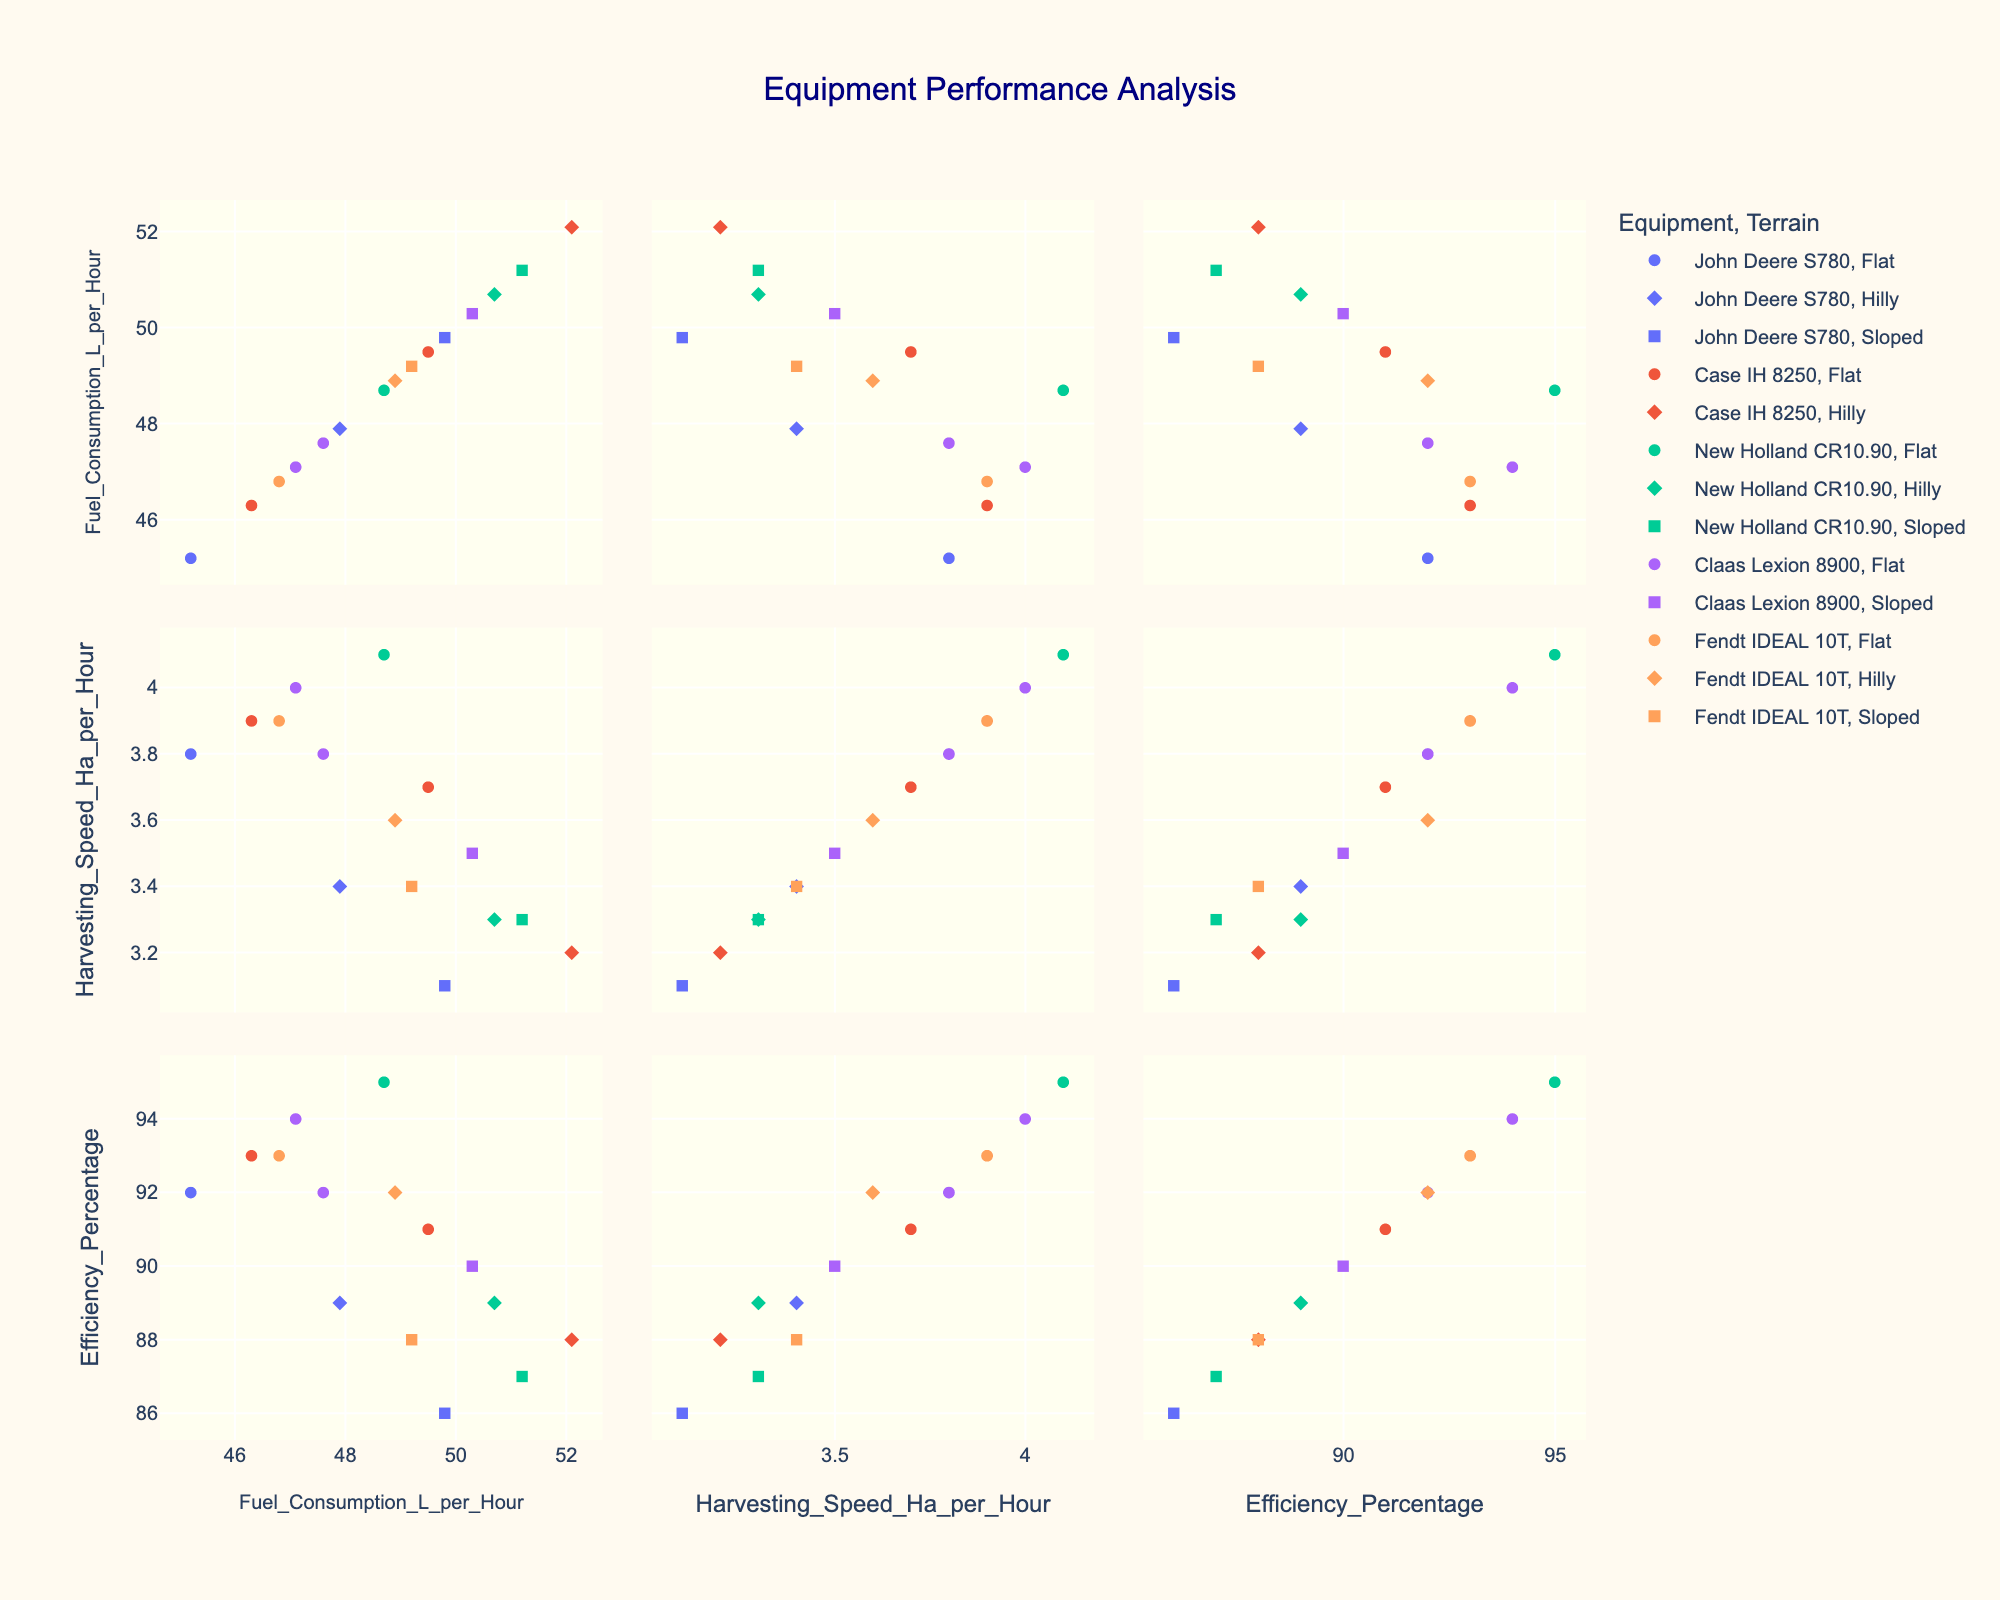What is the title of the scatterplot matrix? The title is usually displayed at the top of the scatterplot matrix.
Answer: Equipment Performance Analysis How many different types of terrains are represented in the plot? The scatterplot matrix uses different symbols to represent different terrain types. By identifying each unique symbol, we can count the number of terrain types.
Answer: Three Which equipment appears to have the highest harvesting speed? By identifying the point with the highest value on the Harvesting_Speed_Ha_per_Hour axis and checking its corresponding Equipment color, we can determine which equipment it is.
Answer: New Holland CR10.90 Are there any negative correlations between Fuel Consumption and Efficiency? Observing the scatterplot panels between Fuel_Consumption_L_per_Hour and Efficiency_Percentage, look for any trends where higher fuel consumption corresponds to lower efficiency.
Answer: Yes What is the general trend between harvesting speed and fuel consumption? By examining the scatterplot panels between Harvesting_Speed_Ha_per_Hour and Fuel_Consumption_L_per_Hour, we can determine if there's a positive, negative, or no clear trend.
Answer: No clear trend Which crop type is associated with the highest efficiency percentage? Identify the data point with the highest Efficiency_Percentage and refer to its hover data to find the crop type.
Answer: Soybeans Do equipment types generally have a similar efficiency percentage across all terrains? Compare the efficiency percentages of the same equipment types across different terrain symbols in the scatterplot matrix.
Answer: No Which two equipment types have the closest average fuel consumption? Calculate or estimate the average fuel consumption for each equipment type by visually assessing their scatter plots, then compare to identify the two closest.
Answer: John Deere S780 and Fendt IDEAL 10T Is there a visible clustering of data points based on crop type within the efficiency percentage vs. harvesting speed plot? Look for groupings of colors or symbols in the scatterplot comparing Efficiency_Percentage and Harvesting_Speed_Ha_per_Hour and identify common crop types.
Answer: Yes, for some crops What is the range of fuel consumption values for flat terrains across all equipment? Identify the minimum and maximum Fuel_Consumption_L_per_Hour for flat terrain points by checking their positions horizontally.
Answer: 45.2 - 50.3 